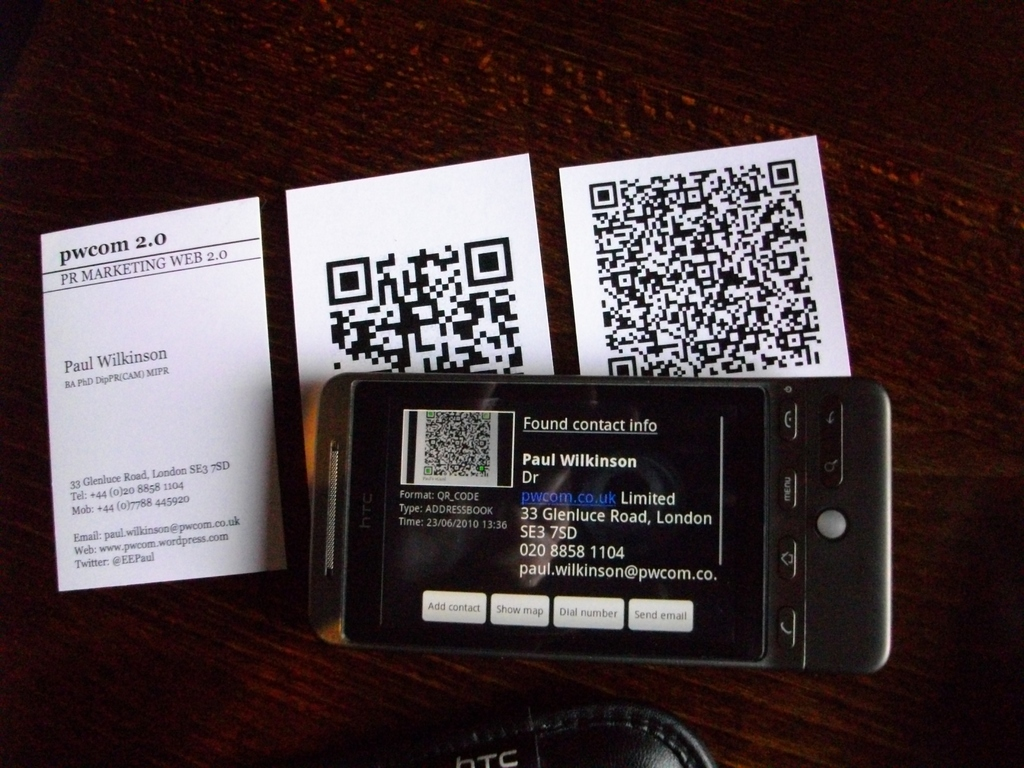What is the significance of the QR codes shown in the image? The QR codes in the image represent a modern approach to marketing and networking, allowing individuals to quickly scan and store contact information directly into their devices, enhancing convenience and connectivity. 